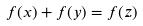<formula> <loc_0><loc_0><loc_500><loc_500>f ( x ) + f ( y ) = f ( z )</formula> 